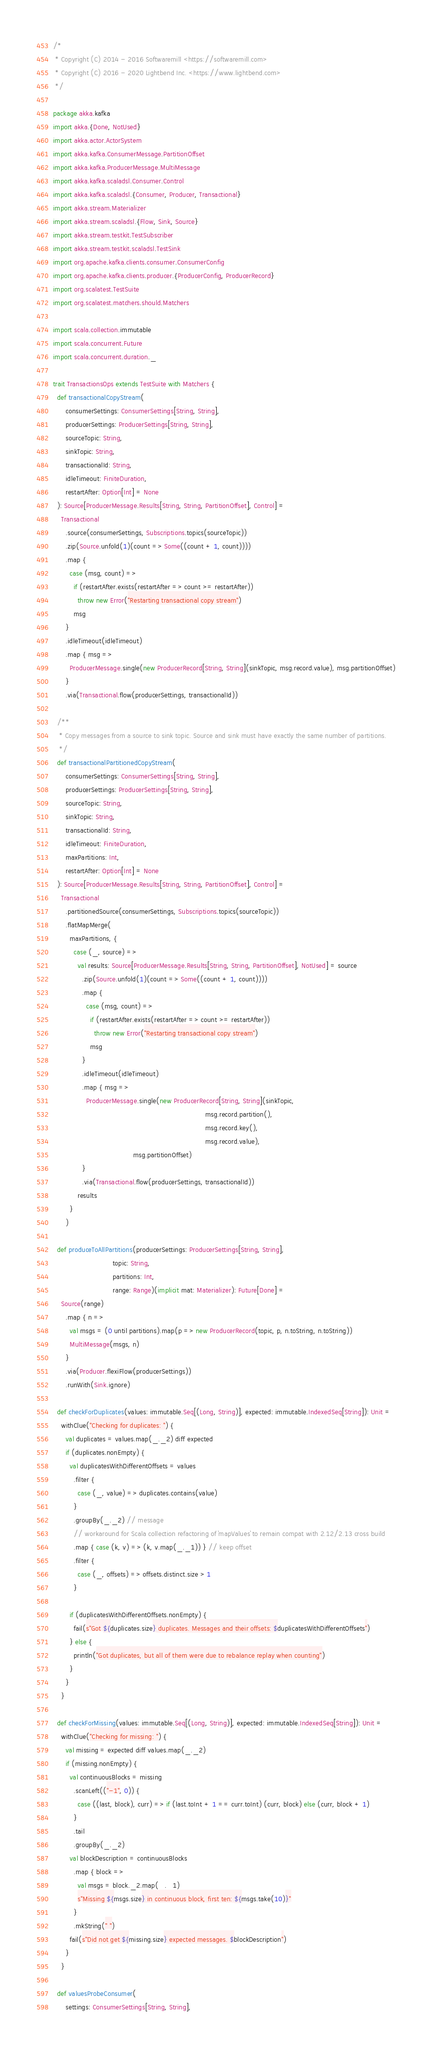<code> <loc_0><loc_0><loc_500><loc_500><_Scala_>/*
 * Copyright (C) 2014 - 2016 Softwaremill <https://softwaremill.com>
 * Copyright (C) 2016 - 2020 Lightbend Inc. <https://www.lightbend.com>
 */

package akka.kafka
import akka.{Done, NotUsed}
import akka.actor.ActorSystem
import akka.kafka.ConsumerMessage.PartitionOffset
import akka.kafka.ProducerMessage.MultiMessage
import akka.kafka.scaladsl.Consumer.Control
import akka.kafka.scaladsl.{Consumer, Producer, Transactional}
import akka.stream.Materializer
import akka.stream.scaladsl.{Flow, Sink, Source}
import akka.stream.testkit.TestSubscriber
import akka.stream.testkit.scaladsl.TestSink
import org.apache.kafka.clients.consumer.ConsumerConfig
import org.apache.kafka.clients.producer.{ProducerConfig, ProducerRecord}
import org.scalatest.TestSuite
import org.scalatest.matchers.should.Matchers

import scala.collection.immutable
import scala.concurrent.Future
import scala.concurrent.duration._

trait TransactionsOps extends TestSuite with Matchers {
  def transactionalCopyStream(
      consumerSettings: ConsumerSettings[String, String],
      producerSettings: ProducerSettings[String, String],
      sourceTopic: String,
      sinkTopic: String,
      transactionalId: String,
      idleTimeout: FiniteDuration,
      restartAfter: Option[Int] = None
  ): Source[ProducerMessage.Results[String, String, PartitionOffset], Control] =
    Transactional
      .source(consumerSettings, Subscriptions.topics(sourceTopic))
      .zip(Source.unfold(1)(count => Some((count + 1, count))))
      .map {
        case (msg, count) =>
          if (restartAfter.exists(restartAfter => count >= restartAfter))
            throw new Error("Restarting transactional copy stream")
          msg
      }
      .idleTimeout(idleTimeout)
      .map { msg =>
        ProducerMessage.single(new ProducerRecord[String, String](sinkTopic, msg.record.value), msg.partitionOffset)
      }
      .via(Transactional.flow(producerSettings, transactionalId))

  /**
   * Copy messages from a source to sink topic. Source and sink must have exactly the same number of partitions.
   */
  def transactionalPartitionedCopyStream(
      consumerSettings: ConsumerSettings[String, String],
      producerSettings: ProducerSettings[String, String],
      sourceTopic: String,
      sinkTopic: String,
      transactionalId: String,
      idleTimeout: FiniteDuration,
      maxPartitions: Int,
      restartAfter: Option[Int] = None
  ): Source[ProducerMessage.Results[String, String, PartitionOffset], Control] =
    Transactional
      .partitionedSource(consumerSettings, Subscriptions.topics(sourceTopic))
      .flatMapMerge(
        maxPartitions, {
          case (_, source) =>
            val results: Source[ProducerMessage.Results[String, String, PartitionOffset], NotUsed] = source
              .zip(Source.unfold(1)(count => Some((count + 1, count))))
              .map {
                case (msg, count) =>
                  if (restartAfter.exists(restartAfter => count >= restartAfter))
                    throw new Error("Restarting transactional copy stream")
                  msg
              }
              .idleTimeout(idleTimeout)
              .map { msg =>
                ProducerMessage.single(new ProducerRecord[String, String](sinkTopic,
                                                                          msg.record.partition(),
                                                                          msg.record.key(),
                                                                          msg.record.value),
                                       msg.partitionOffset)
              }
              .via(Transactional.flow(producerSettings, transactionalId))
            results
        }
      )

  def produceToAllPartitions(producerSettings: ProducerSettings[String, String],
                             topic: String,
                             partitions: Int,
                             range: Range)(implicit mat: Materializer): Future[Done] =
    Source(range)
      .map { n =>
        val msgs = (0 until partitions).map(p => new ProducerRecord(topic, p, n.toString, n.toString))
        MultiMessage(msgs, n)
      }
      .via(Producer.flexiFlow(producerSettings))
      .runWith(Sink.ignore)

  def checkForDuplicates(values: immutable.Seq[(Long, String)], expected: immutable.IndexedSeq[String]): Unit =
    withClue("Checking for duplicates: ") {
      val duplicates = values.map(_._2) diff expected
      if (duplicates.nonEmpty) {
        val duplicatesWithDifferentOffsets = values
          .filter {
            case (_, value) => duplicates.contains(value)
          }
          .groupBy(_._2) // message
          // workaround for Scala collection refactoring of `mapValues` to remain compat with 2.12/2.13 cross build
          .map { case (k, v) => (k, v.map(_._1)) } // keep offset
          .filter {
            case (_, offsets) => offsets.distinct.size > 1
          }

        if (duplicatesWithDifferentOffsets.nonEmpty) {
          fail(s"Got ${duplicates.size} duplicates. Messages and their offsets: $duplicatesWithDifferentOffsets")
        } else {
          println("Got duplicates, but all of them were due to rebalance replay when counting")
        }
      }
    }

  def checkForMissing(values: immutable.Seq[(Long, String)], expected: immutable.IndexedSeq[String]): Unit =
    withClue("Checking for missing: ") {
      val missing = expected diff values.map(_._2)
      if (missing.nonEmpty) {
        val continuousBlocks = missing
          .scanLeft(("-1", 0)) {
            case ((last, block), curr) => if (last.toInt + 1 == curr.toInt) (curr, block) else (curr, block + 1)
          }
          .tail
          .groupBy(_._2)
        val blockDescription = continuousBlocks
          .map { block =>
            val msgs = block._2.map(_._1)
            s"Missing ${msgs.size} in continuous block, first ten: ${msgs.take(10)}"
          }
          .mkString(" ")
        fail(s"Did not get ${missing.size} expected messages. $blockDescription")
      }
    }

  def valuesProbeConsumer(
      settings: ConsumerSettings[String, String],</code> 